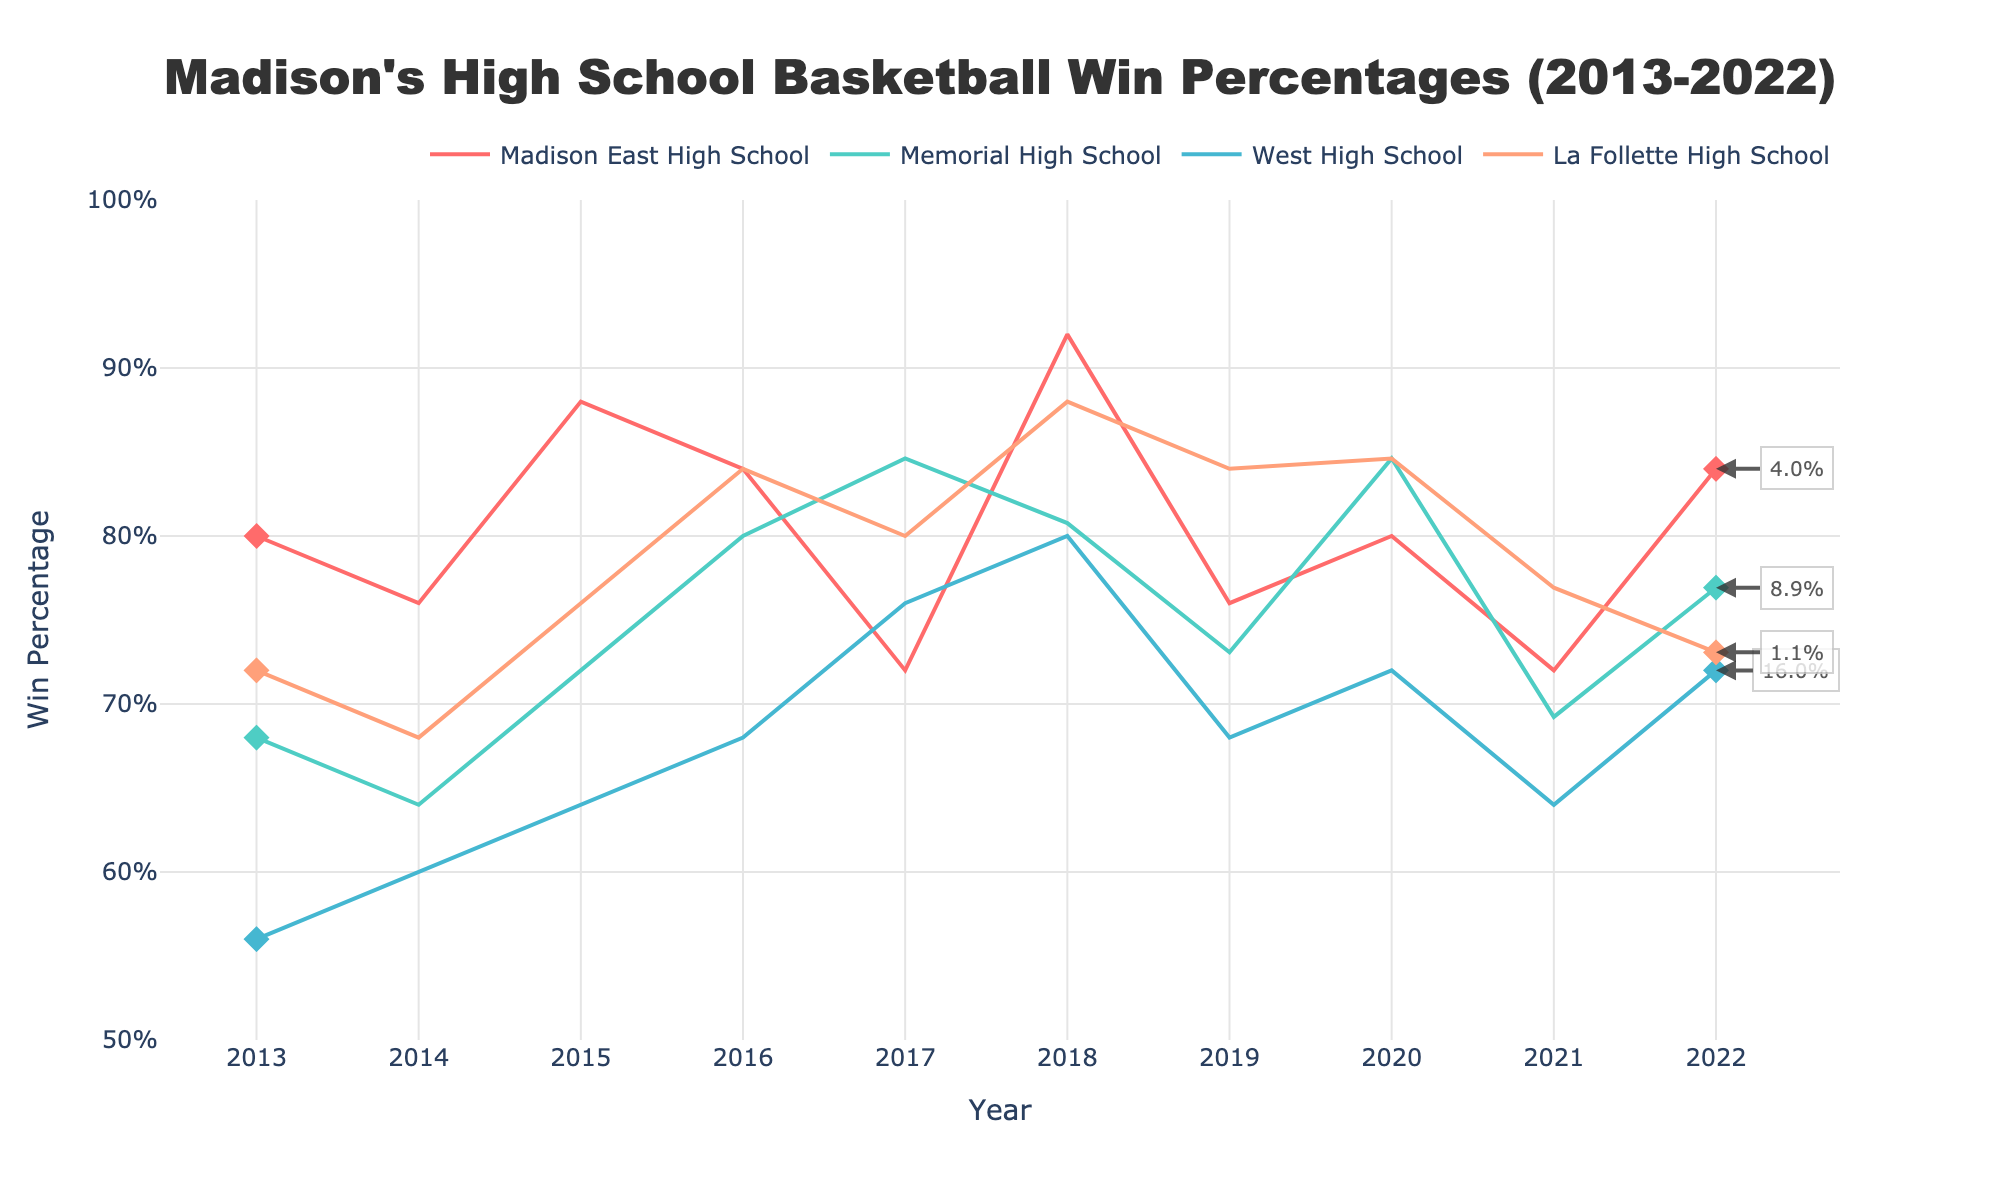What is the title of the figure? The title is displayed at the top center of the plot. It provides a summary of what the plot is about. In this case, the title is "Madison's High School Basketball Win Percentages (2013-2022)."
Answer: Madison's High School Basketball Win Percentages (2013-2022) What is the win percentage for Memorial High School in 2020? To find this, look at the line corresponding to Memorial High School and check the y-axis value where it intersects with the year 2020 on the x-axis.
Answer: 84.6% Which school had the highest win percentage in 2018, and what was it? Look at the year 2018 on the x-axis and find the highest y-axis value among all the lines. The corresponding line will indicate the school.
Answer: Madison East High School, 92.0% How did Madison East High School's win percentage change from 2013 to 2022? First, find Madison East High School's points for 2013 and 2022 on the plot. Compare the y-axis values to calculate the change. The annotation indicates the change.
Answer: +2.9% Compare the win percentages of La Follette High School and West High School in 2015. Which school had a higher win percentage and by how much? Find the points for both schools in the year 2015. Compare their y-axis values to see which is higher and calculate the difference. La Follette had 76.0% and West had 64.0%.
Answer: La Follette High School by 12.0% Which school exhibited the most improvement in their win percentage over the decade? Look at the annotations at the end of the lines in 2022 to find the greatest positive change from 2013 to 2022. Each annotation shows the change.
Answer: Memorial High School What was the approximate average win percentage for West High School throughout the decade? To estimate this, average the y-axis values at each year for the line corresponding to West High School.
Answer: Approximately 66.2% How many schools ended the decade with a lower win percentage than they started? Check the annotations at the end of the lines in 2022. If the annotation shows a negative change, count those occurrences.
Answer: None Which school had the smallest fluctuation in win percentage over the decade? Look for the school whose line on the plot is the most stable with the least variation in its y-axis values over the years.
Answer: West High School How did La Follette High School's win percentage trend from 2016 to 2022? Observe the La Follette High School line from 2016 to 2022. Check the slope direction to understand the trend.
Answer: Slightly downwards 